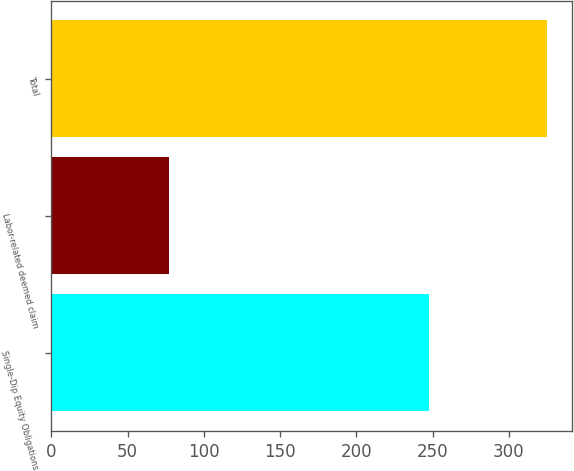<chart> <loc_0><loc_0><loc_500><loc_500><bar_chart><fcel>Single-Dip Equity Obligations<fcel>Labor-related deemed claim<fcel>Total<nl><fcel>248<fcel>77<fcel>325<nl></chart> 